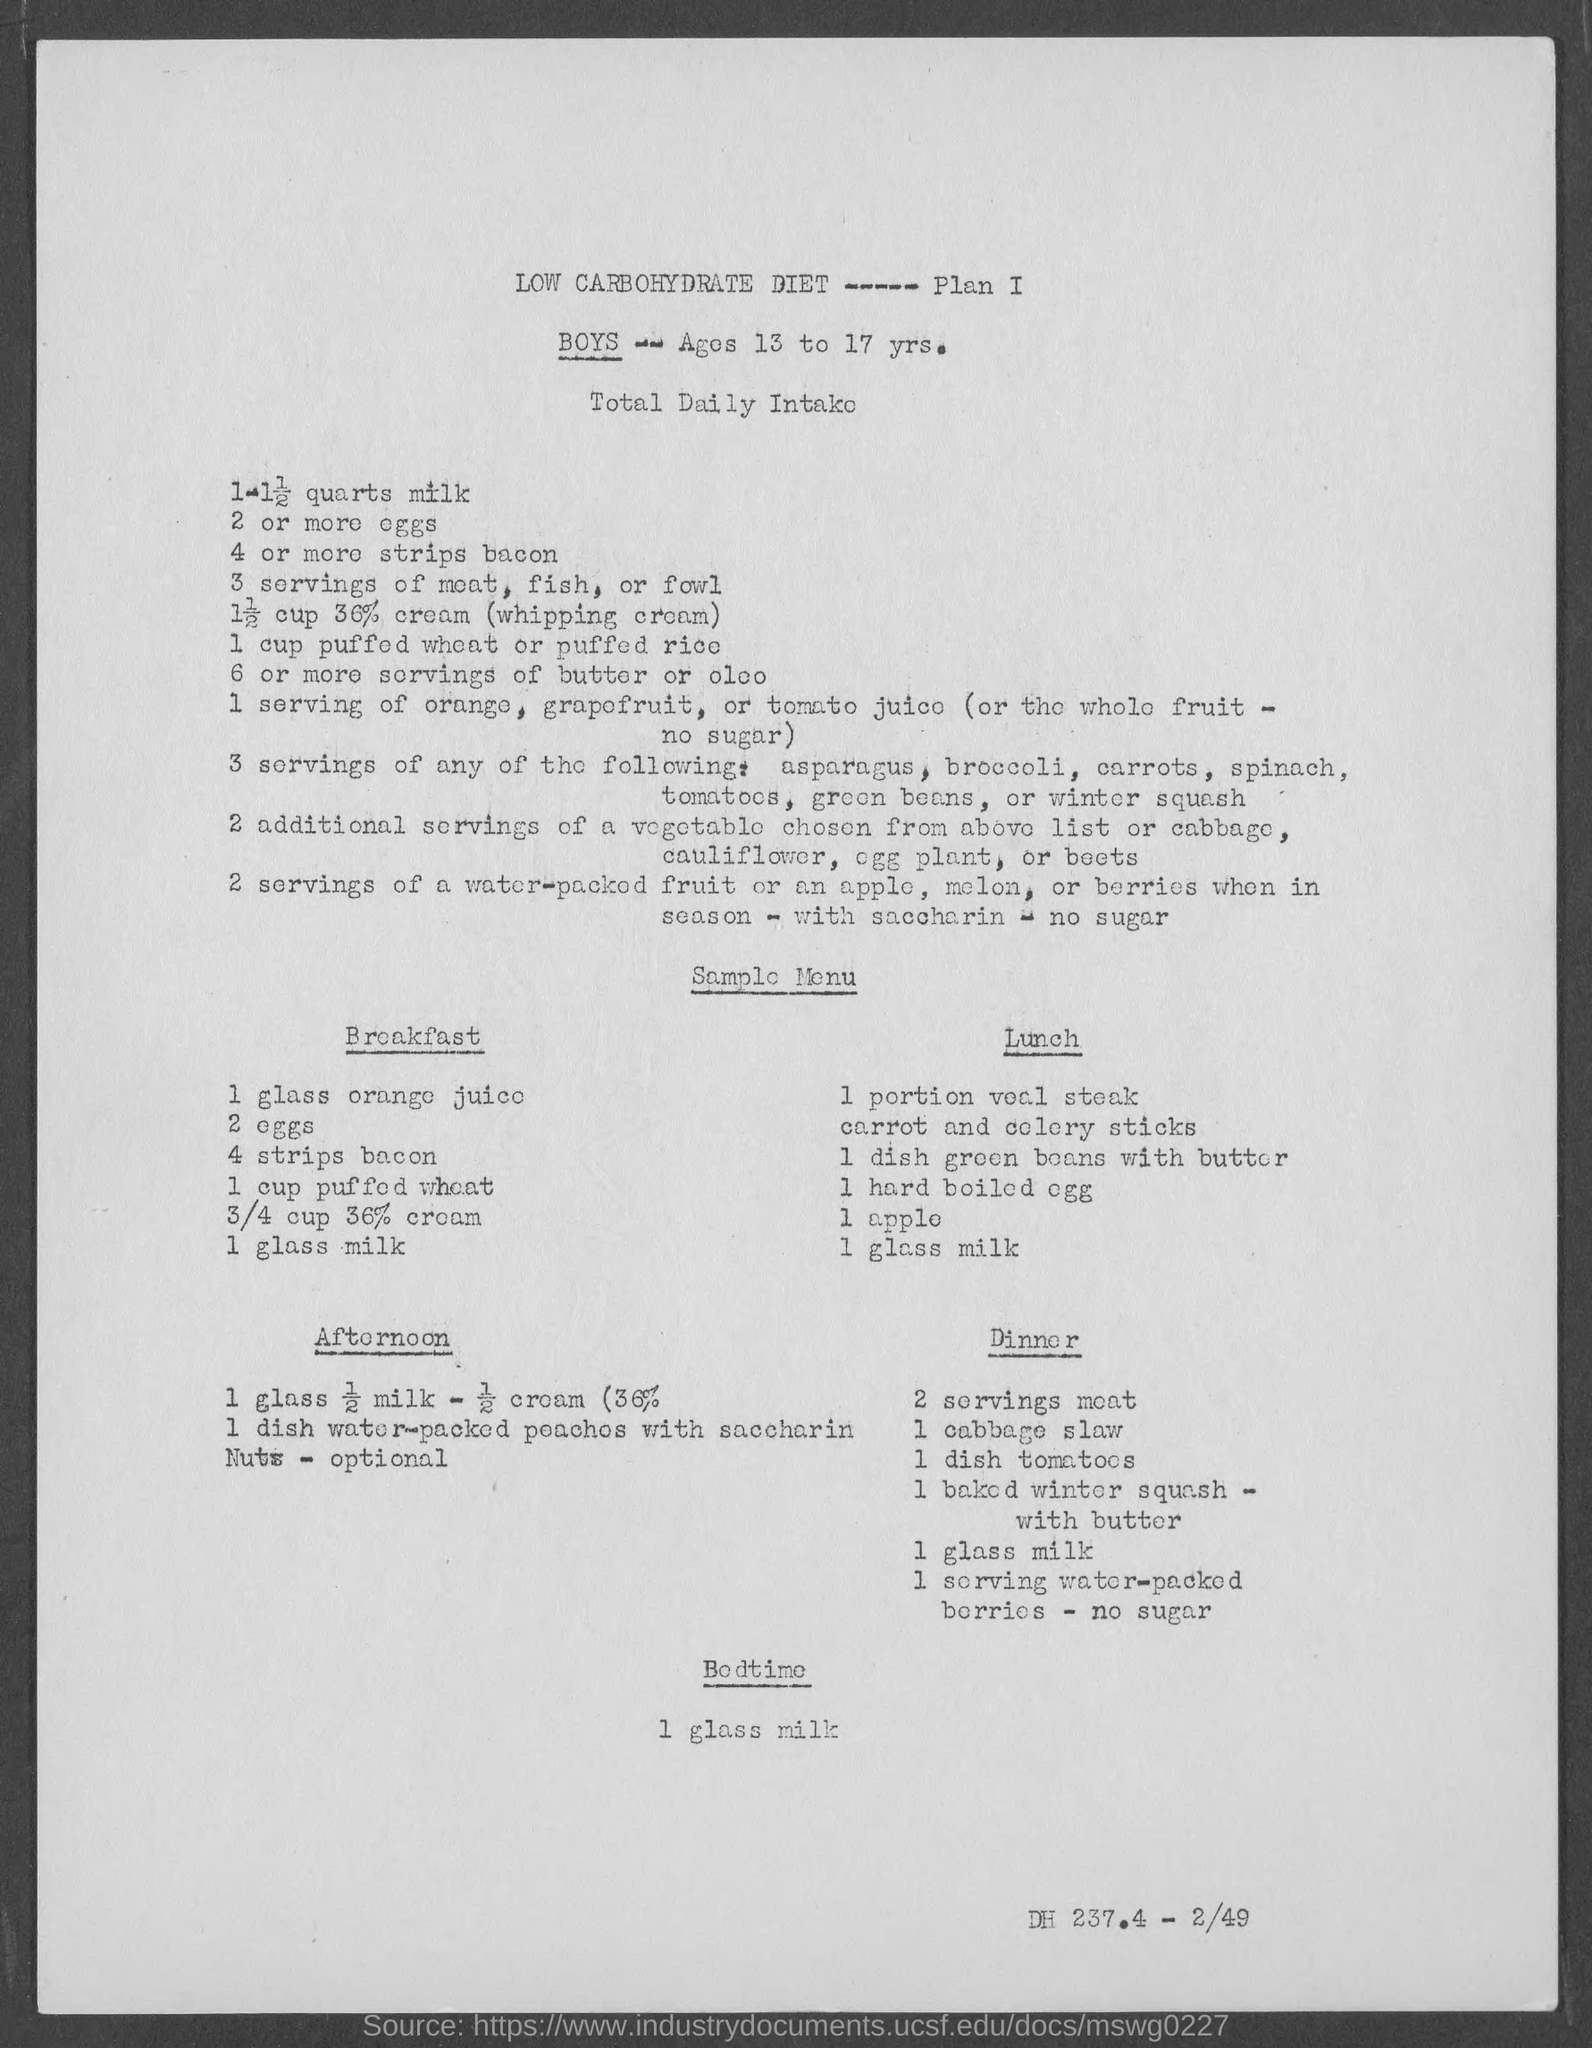List a handful of essential elements in this visual. 36% of whipping cream was added. According to the diet plan, the third item for breakfast is 4 strips of bacon. According to the diet plan, the second item for breakfast is two eggs. According to the diet plan, the fourth item for breakfast is one cup of puffed wheat. The age of the boys ranges from 13 to 17 years old. 